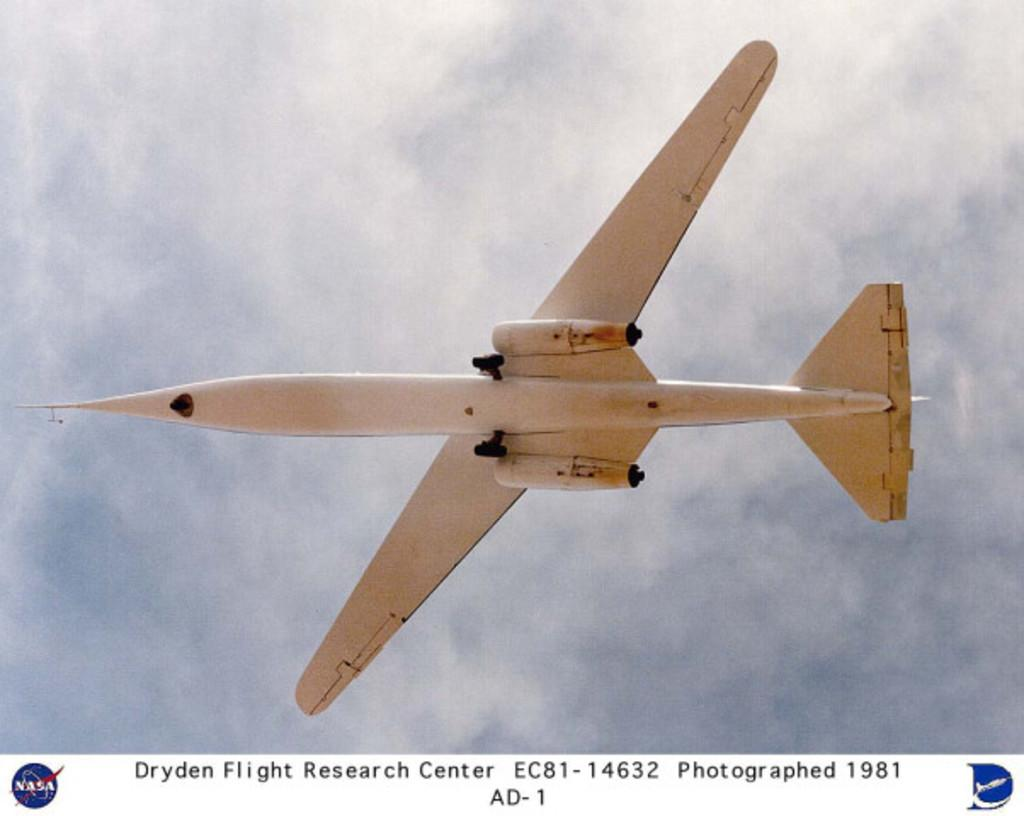What is the main subject of the image? The main subject of the image is a plane. What color is the plane? The plane is white in color. What is the plane doing in the image? The plane is flying. What can be seen below the plane in the image? There is text written below the plane. What teaching method is being used by the plane in the image? There is no teaching method being used by the plane in the image, as it is a flying object and not an educator. 